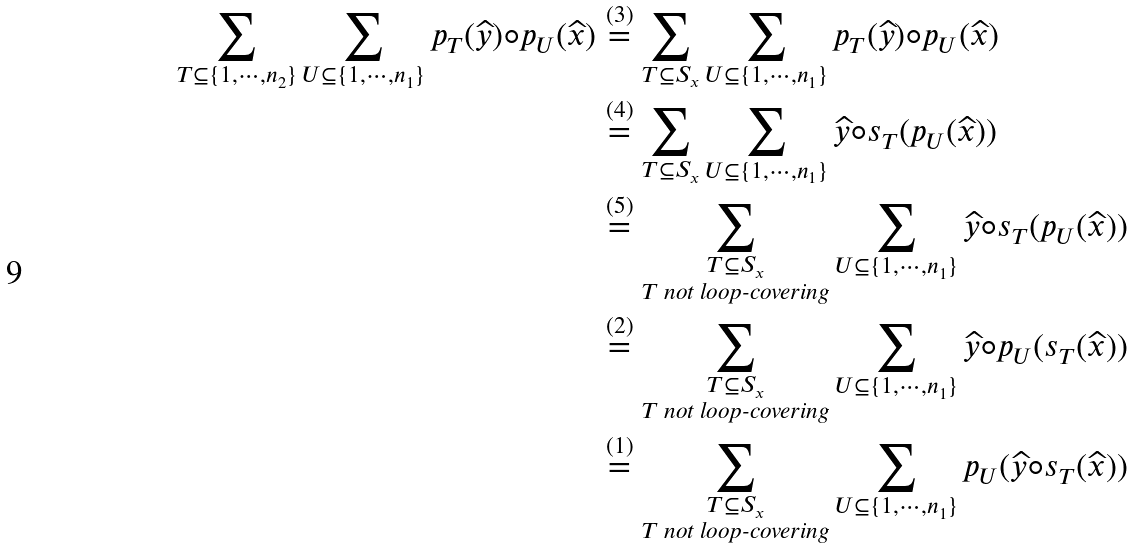Convert formula to latex. <formula><loc_0><loc_0><loc_500><loc_500>\sum _ { T \subseteq \{ 1 , \cdots , n _ { 2 } \} } \sum _ { U \subseteq \{ 1 , \cdots , n _ { 1 } \} } p _ { T } ( \widehat { y } ) \circ p _ { U } ( \widehat { x } ) & \stackrel { ( 3 ) } { = } \sum _ { T \subseteq S _ { x } } \sum _ { U \subseteq \{ 1 , \cdots , n _ { 1 } \} } p _ { T } ( \widehat { y } ) \circ p _ { U } ( \widehat { x } ) \\ & \stackrel { ( 4 ) } { = } \sum _ { T \subseteq S _ { x } } \sum _ { U \subseteq \{ 1 , \cdots , n _ { 1 } \} } \widehat { y } \circ s _ { T } ( p _ { U } ( \widehat { x } ) ) \\ & \stackrel { ( 5 ) } { = } \sum _ { \substack { T \subseteq { S } _ { x } \\ T \text { not loop-covering} } } \sum _ { U \subseteq \{ 1 , \cdots , n _ { 1 } \} } \widehat { y } \circ s _ { T } ( p _ { U } ( \widehat { x } ) ) \\ & \stackrel { ( 2 ) } { = } \sum _ { \substack { T \subseteq { S } _ { x } \\ T \text { not loop-covering} } } \sum _ { U \subseteq \{ 1 , \cdots , n _ { 1 } \} } \widehat { y } \circ p _ { U } ( s _ { T } ( \widehat { x } ) ) \\ & \stackrel { ( 1 ) } { = } \sum _ { \substack { T \subseteq { S } _ { x } \\ T \text { not loop-covering} } } \sum _ { U \subseteq \{ 1 , \cdots , n _ { 1 } \} } p _ { U } ( \widehat { y } \circ s _ { T } ( \widehat { x } ) )</formula> 